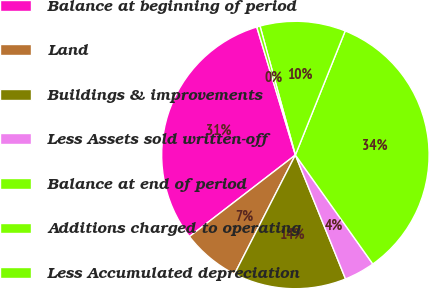Convert chart to OTSL. <chart><loc_0><loc_0><loc_500><loc_500><pie_chart><fcel>Balance at beginning of period<fcel>Land<fcel>Buildings & improvements<fcel>Less Assets sold written-off<fcel>Balance at end of period<fcel>Additions charged to operating<fcel>Less Accumulated depreciation<nl><fcel>30.78%<fcel>7.03%<fcel>13.65%<fcel>3.71%<fcel>34.09%<fcel>10.34%<fcel>0.4%<nl></chart> 